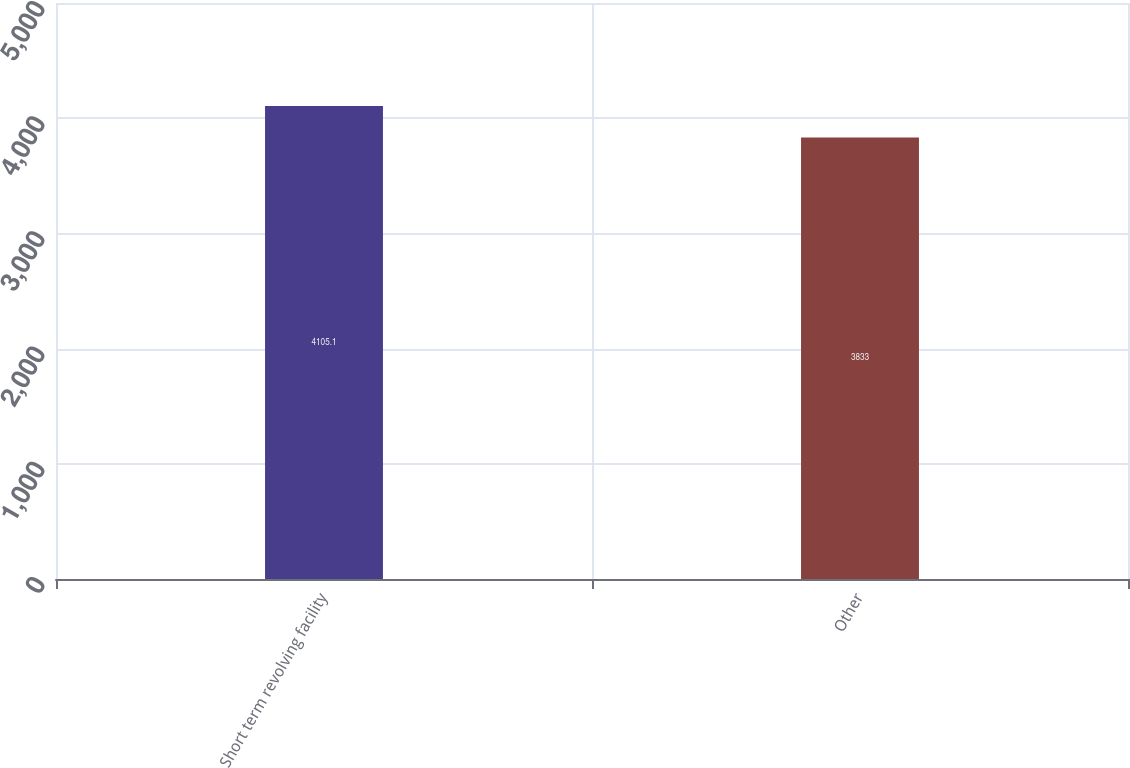Convert chart to OTSL. <chart><loc_0><loc_0><loc_500><loc_500><bar_chart><fcel>Short term revolving facility<fcel>Other<nl><fcel>4105.1<fcel>3833<nl></chart> 